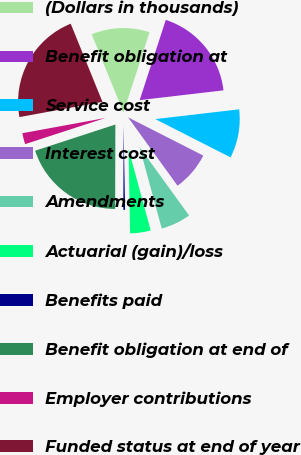Convert chart. <chart><loc_0><loc_0><loc_500><loc_500><pie_chart><fcel>(Dollars in thousands)<fcel>Benefit obligation at<fcel>Service cost<fcel>Interest cost<fcel>Amendments<fcel>Actuarial (gain)/loss<fcel>Benefits paid<fcel>Benefit obligation at end of<fcel>Employer contributions<fcel>Funded status at end of year<nl><fcel>11.15%<fcel>18.14%<fcel>9.34%<fcel>7.54%<fcel>5.74%<fcel>3.94%<fcel>0.33%<fcel>19.94%<fcel>2.13%<fcel>21.74%<nl></chart> 